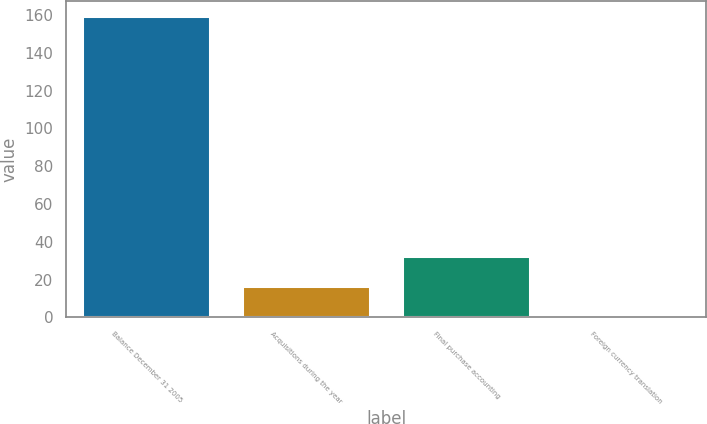Convert chart. <chart><loc_0><loc_0><loc_500><loc_500><bar_chart><fcel>Balance December 31 2005<fcel>Acquisitions during the year<fcel>Final purchase accounting<fcel>Foreign currency translation<nl><fcel>159.3<fcel>16.47<fcel>32.34<fcel>0.6<nl></chart> 